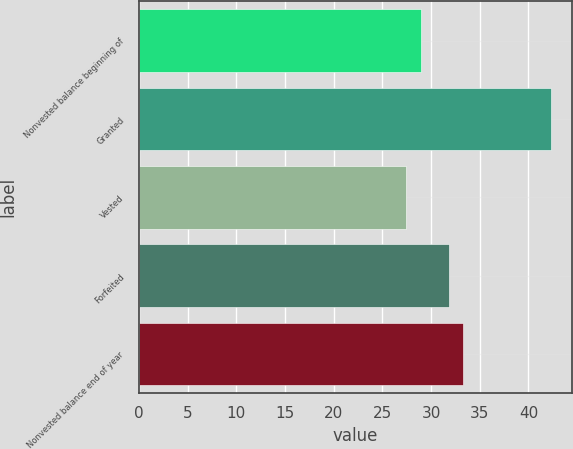<chart> <loc_0><loc_0><loc_500><loc_500><bar_chart><fcel>Nonvested balance beginning of<fcel>Granted<fcel>Vested<fcel>Forfeited<fcel>Nonvested balance end of year<nl><fcel>28.96<fcel>42.36<fcel>27.47<fcel>31.81<fcel>33.3<nl></chart> 